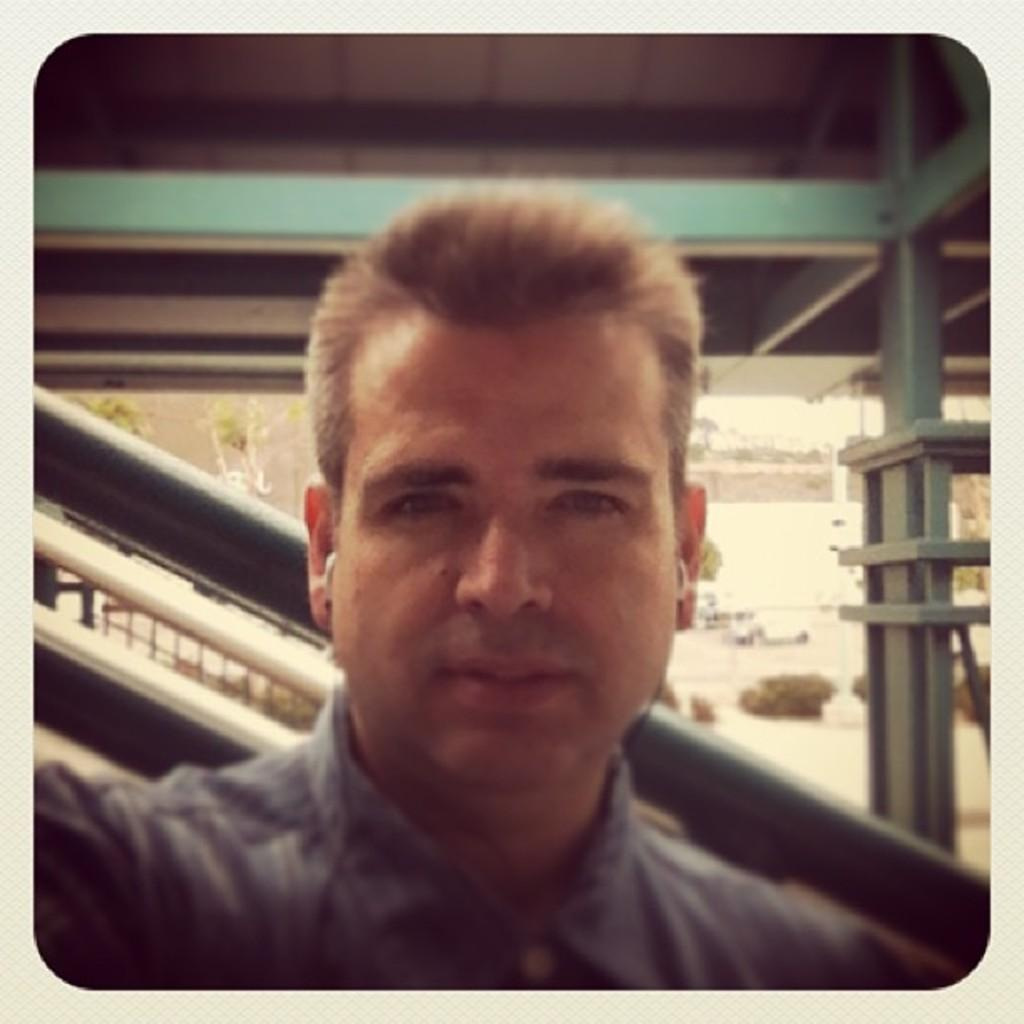Who is present in the image? There is a man in the image. What type of vegetation can be seen in the image? Plants are visible in the image. What are the rods used for in the image? The purpose of the rods is not specified in the image. Can you describe the objects in the image? There are some objects in the image, but their specific nature is not mentioned in the facts. What is visible in the background of the image? The sky is visible in the background of the image. What type of worm can be seen crawling on the man's shoulder in the image? There is no worm present in the image; only a man, plants, rods, objects, and the sky are visible. 